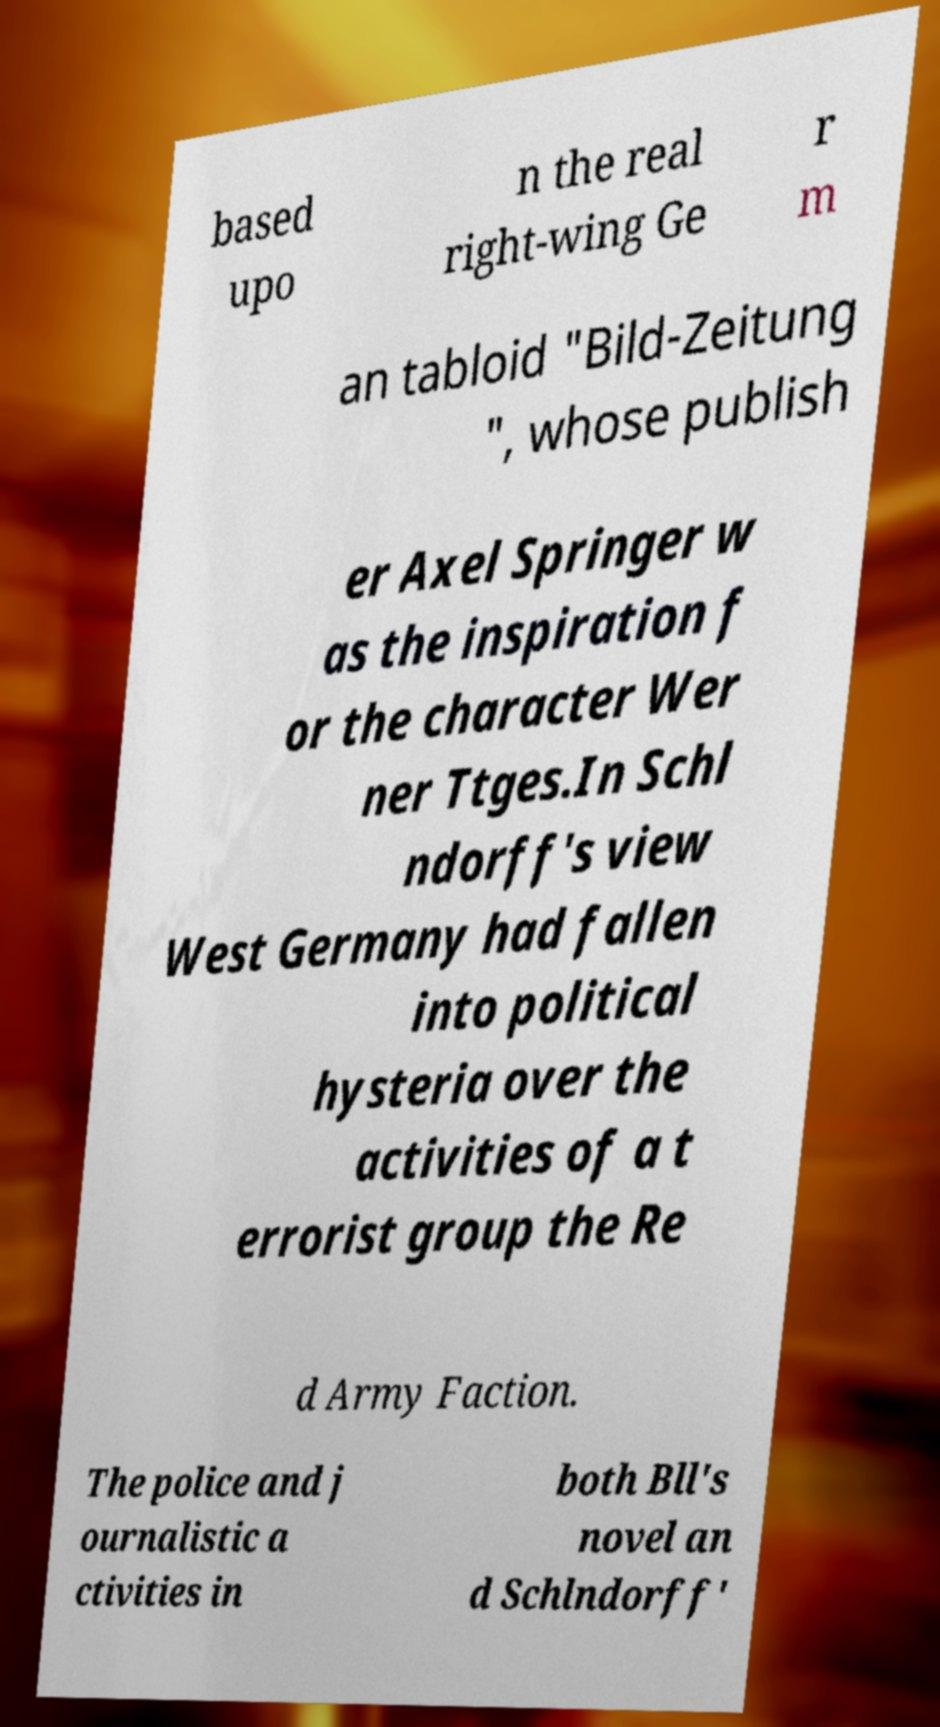I need the written content from this picture converted into text. Can you do that? based upo n the real right-wing Ge r m an tabloid "Bild-Zeitung ", whose publish er Axel Springer w as the inspiration f or the character Wer ner Ttges.In Schl ndorff's view West Germany had fallen into political hysteria over the activities of a t errorist group the Re d Army Faction. The police and j ournalistic a ctivities in both Bll's novel an d Schlndorff' 